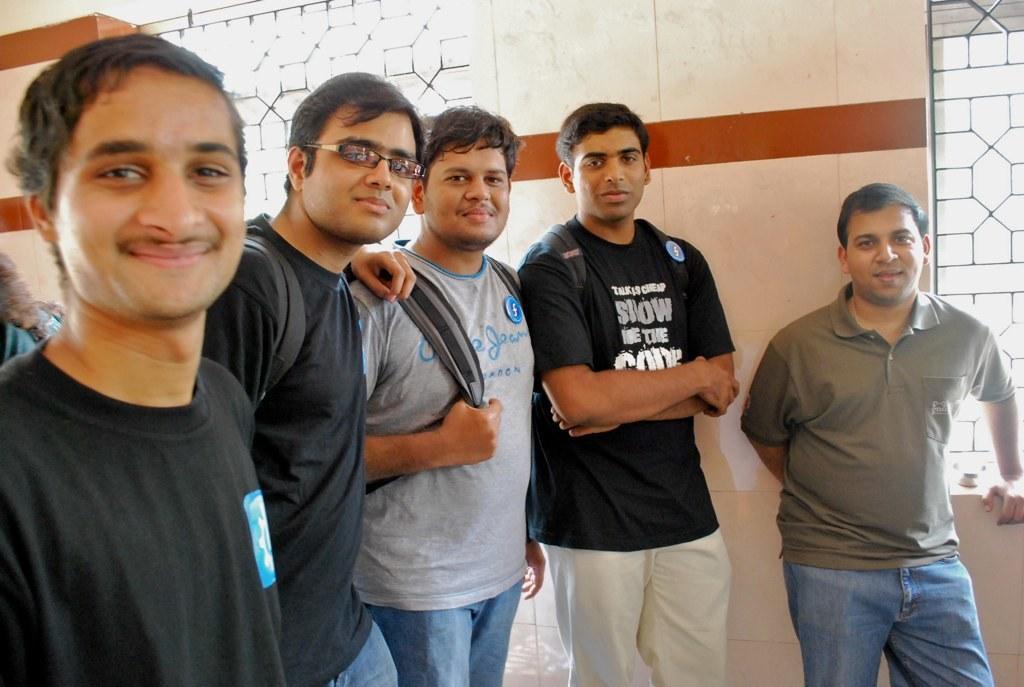Can you describe this image briefly? In the center of the image we can see people standing and smiling. In the background there is a wall and we can see grills. 